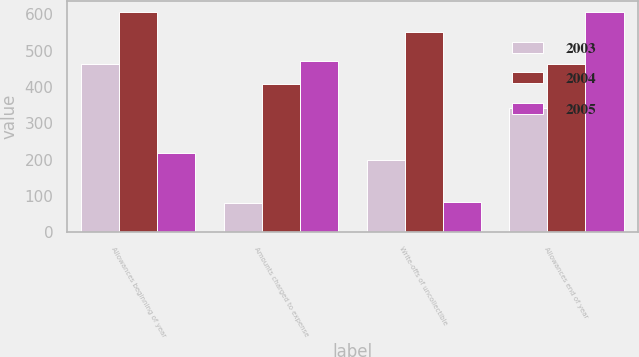Convert chart. <chart><loc_0><loc_0><loc_500><loc_500><stacked_bar_chart><ecel><fcel>Allowances beginning of year<fcel>Amounts charged to expense<fcel>Write-offs of uncollectible<fcel>Allowances end of year<nl><fcel>2003<fcel>462<fcel>80<fcel>199<fcel>343<nl><fcel>2004<fcel>607<fcel>407<fcel>552<fcel>462<nl><fcel>2005<fcel>219<fcel>472<fcel>84<fcel>607<nl></chart> 